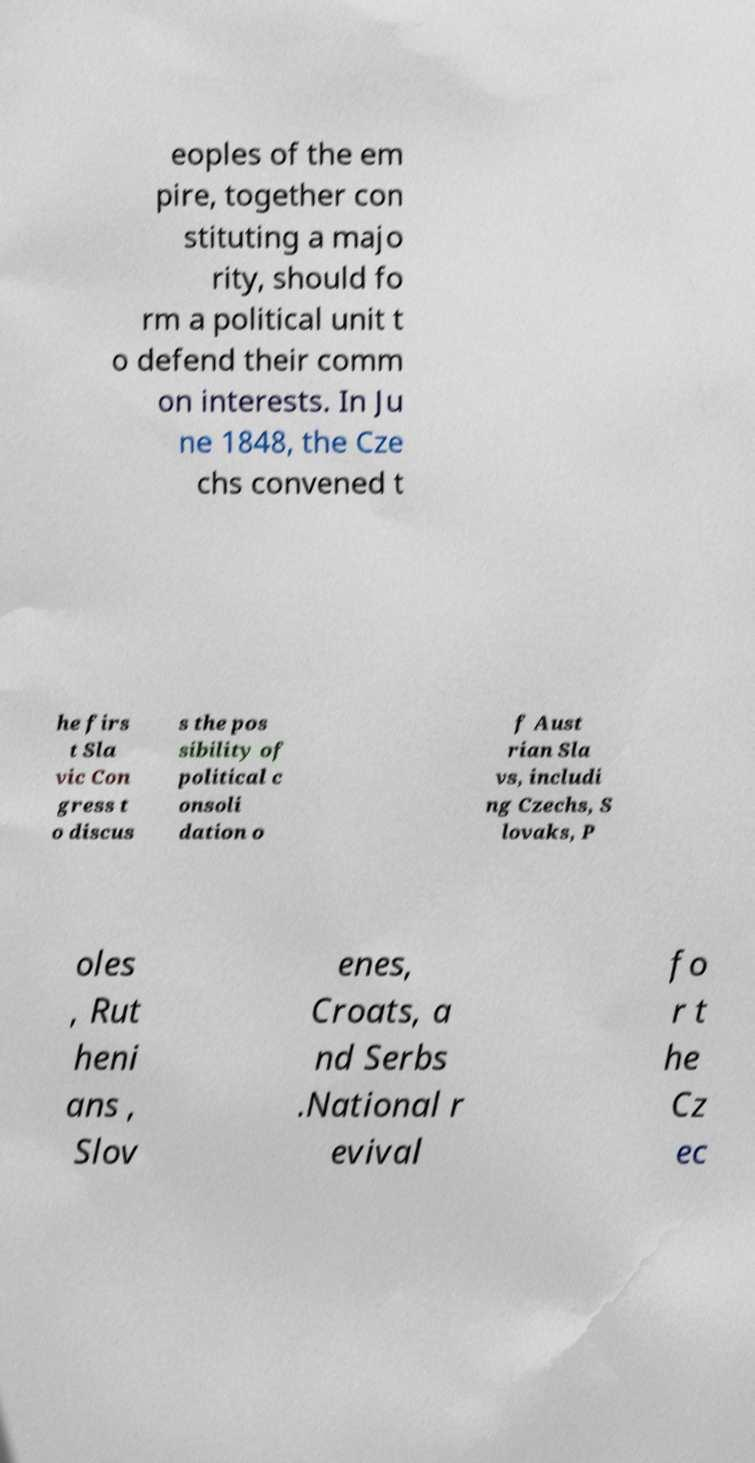Could you extract and type out the text from this image? eoples of the em pire, together con stituting a majo rity, should fo rm a political unit t o defend their comm on interests. In Ju ne 1848, the Cze chs convened t he firs t Sla vic Con gress t o discus s the pos sibility of political c onsoli dation o f Aust rian Sla vs, includi ng Czechs, S lovaks, P oles , Rut heni ans , Slov enes, Croats, a nd Serbs .National r evival fo r t he Cz ec 